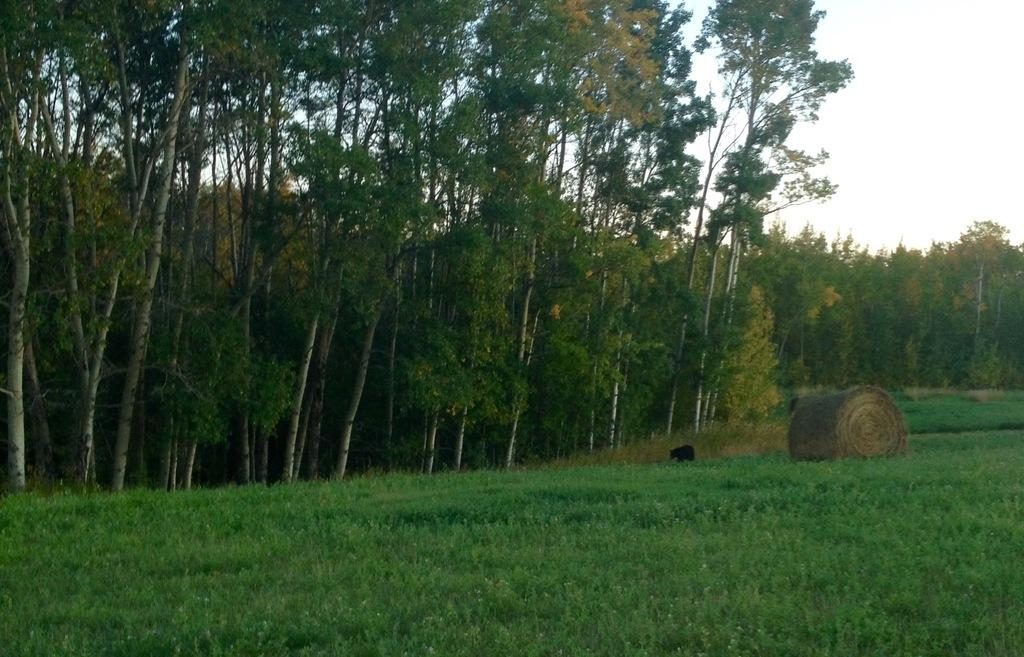What type of vegetation is present on the ground in the image? There is grass on the ground in the image. What can be seen in the middle of the image? There are many trees in the middle of the image. What is visible in the background of the image? The sky is visible in the background of the image. How many bits can be seen in the image? There are no bits present in the image. What trick is being performed by the trees in the middle of the image? There is no trick being performed by the trees in the image; they are simply standing in the middle of the image. 